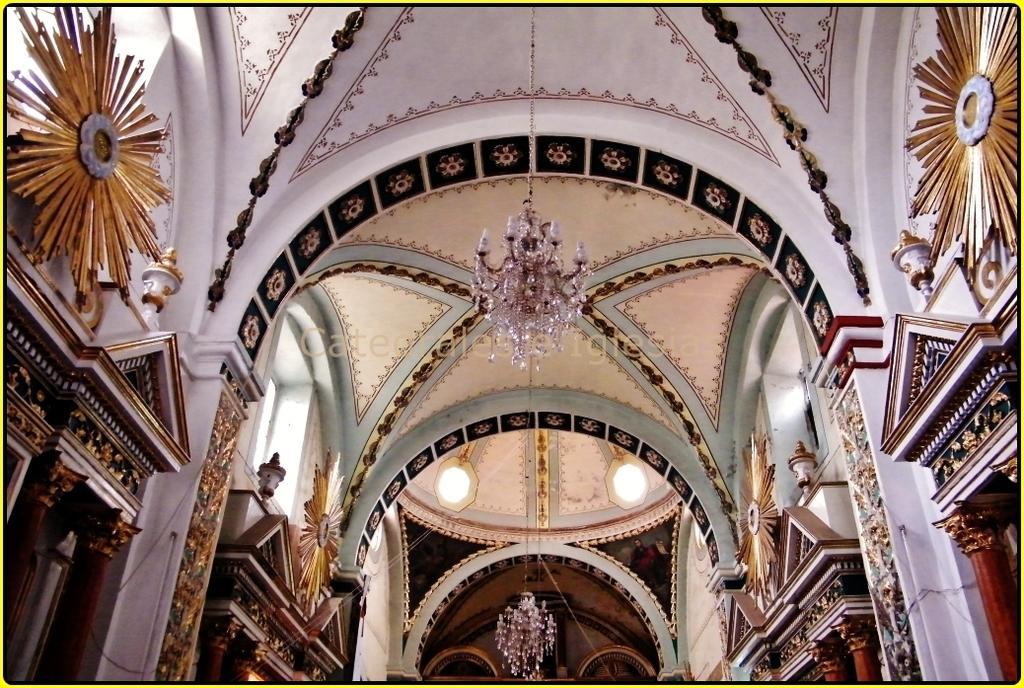In one or two sentences, can you explain what this image depicts? In this picture, we see a white wall and pillars. This picture might be clicked inside the museum or a building. Here, we see the lanterns. In the middle of the picture, we see the chandelier. At the top of the picture, we see the roof of the building. 